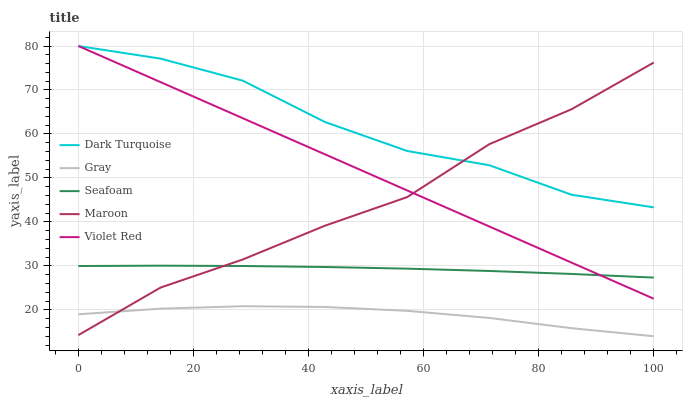Does Gray have the minimum area under the curve?
Answer yes or no. Yes. Does Dark Turquoise have the maximum area under the curve?
Answer yes or no. Yes. Does Violet Red have the minimum area under the curve?
Answer yes or no. No. Does Violet Red have the maximum area under the curve?
Answer yes or no. No. Is Violet Red the smoothest?
Answer yes or no. Yes. Is Dark Turquoise the roughest?
Answer yes or no. Yes. Is Seafoam the smoothest?
Answer yes or no. No. Is Seafoam the roughest?
Answer yes or no. No. Does Violet Red have the lowest value?
Answer yes or no. No. Does Seafoam have the highest value?
Answer yes or no. No. Is Gray less than Seafoam?
Answer yes or no. Yes. Is Seafoam greater than Gray?
Answer yes or no. Yes. Does Gray intersect Seafoam?
Answer yes or no. No. 